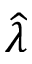<formula> <loc_0><loc_0><loc_500><loc_500>\widehat { \lambda }</formula> 